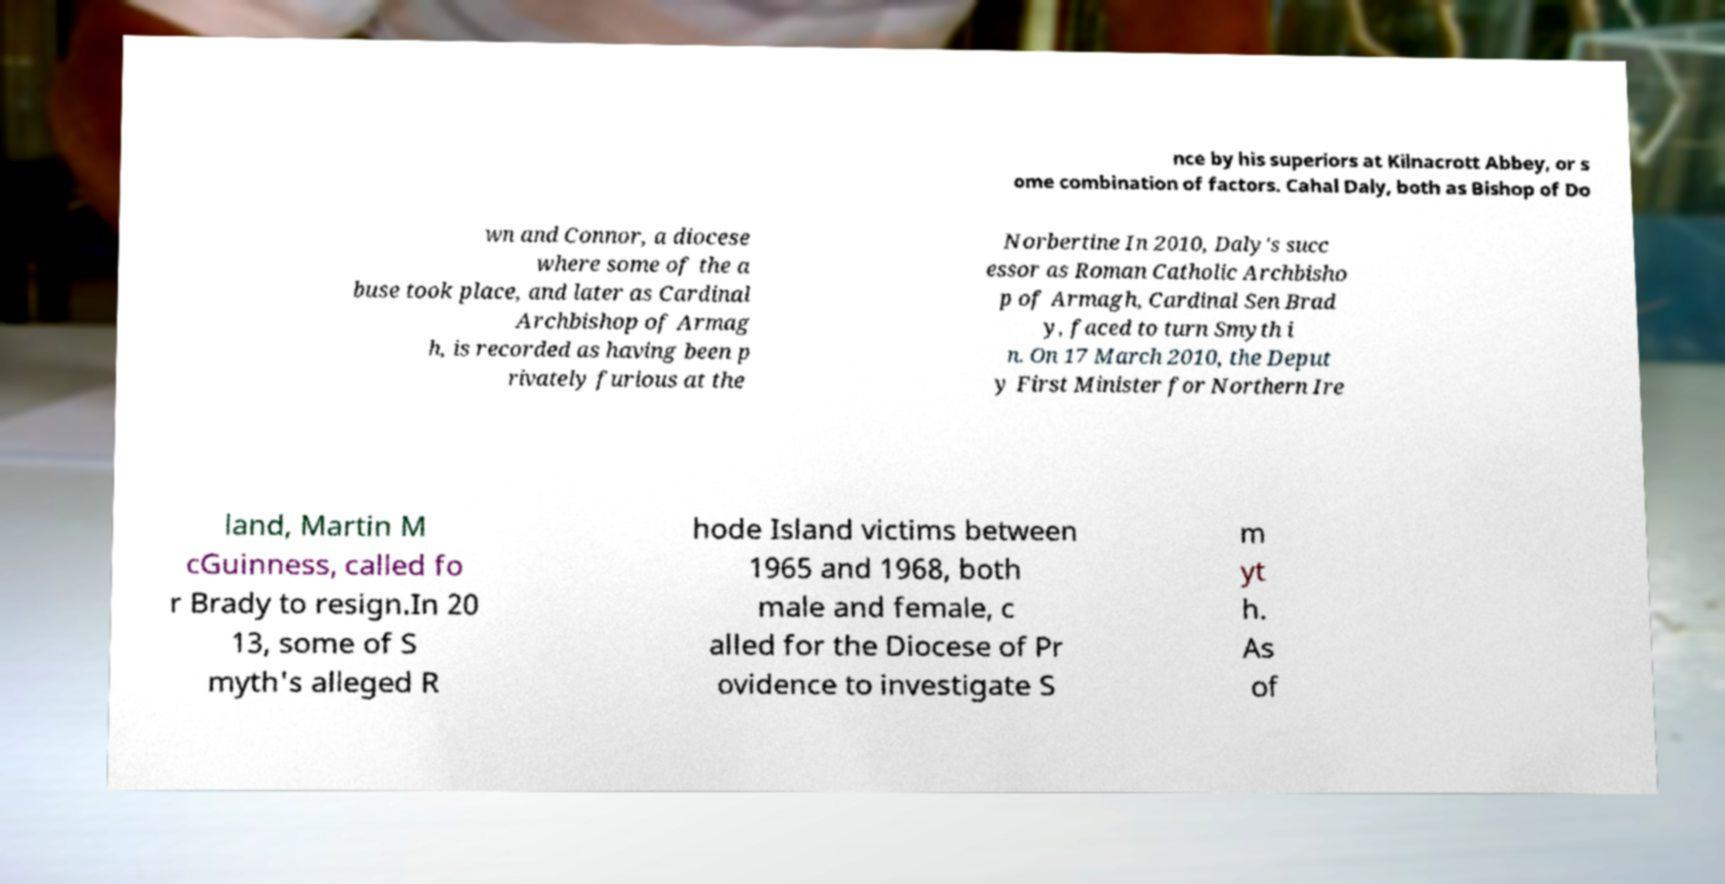What messages or text are displayed in this image? I need them in a readable, typed format. nce by his superiors at Kilnacrott Abbey, or s ome combination of factors. Cahal Daly, both as Bishop of Do wn and Connor, a diocese where some of the a buse took place, and later as Cardinal Archbishop of Armag h, is recorded as having been p rivately furious at the Norbertine In 2010, Daly's succ essor as Roman Catholic Archbisho p of Armagh, Cardinal Sen Brad y, faced to turn Smyth i n. On 17 March 2010, the Deput y First Minister for Northern Ire land, Martin M cGuinness, called fo r Brady to resign.In 20 13, some of S myth's alleged R hode Island victims between 1965 and 1968, both male and female, c alled for the Diocese of Pr ovidence to investigate S m yt h. As of 